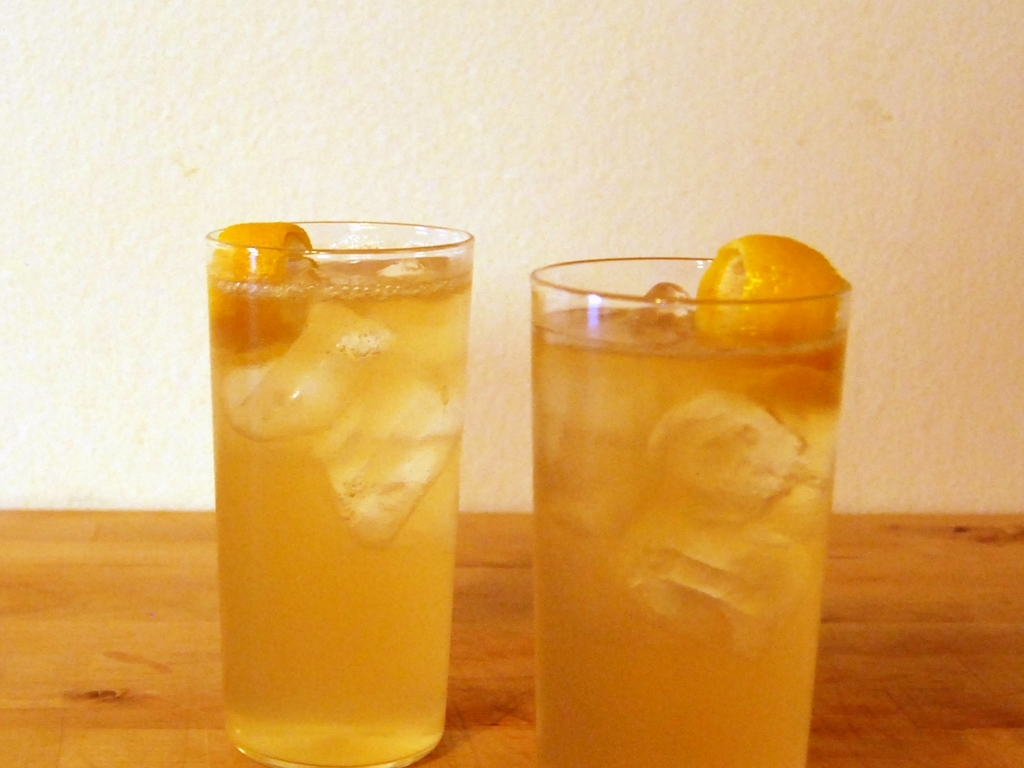Is the composition good? The choice of answer as 'B. No' suggests that the composition could be improved. However, upon reviewing the image, the composition is balanced with two glasses equally centered, a clean background that doesn't distract from the subject, and an overall symmetry that is pleasing to the eye. Therefore, a more fitting assessment would be 'A. Yes', the composition is indeed good, providing a simple yet effective visual presentation of the drinks. 